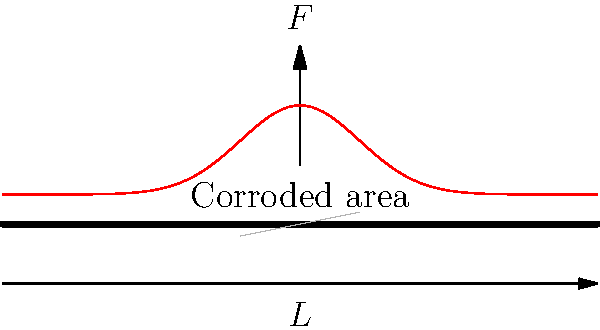Consider a corroded pipe section subjected to an axial load $F$ as shown in the figure. The pipe has length $L$ and the corroded area is located at the center. Using finite element analysis, the stress distribution along the pipe's length is plotted (red curve). What can be inferred about the stress concentration in the corroded area, and how might this affect the pipe's integrity over time? To analyze the stress distribution in the corroded pipe section:

1. Observe the stress distribution curve (red line):
   - The curve shows a peak at the center of the pipe where the corrosion is located.

2. Understand stress concentration:
   - Stress concentration occurs in areas where there are sudden changes in geometry or material properties.
   - The corroded area represents a reduction in pipe wall thickness, causing a stress concentration.

3. Analyze the peak stress:
   - The maximum stress occurs at the center of the corroded area.
   - This peak stress is significantly higher than the stress in the uncorroded sections.

4. Consider Saint-Venant's principle:
   - The stress concentration effect diminishes as we move away from the corroded area.

5. Evaluate the impact on pipe integrity:
   - The higher stress in the corroded area increases the risk of failure.
   - Over time, this stress concentration can lead to:
     a) Further corrosion acceleration
     b) Crack initiation and propagation
     c) Potential pipe rupture under continued loading

6. Long-term effects:
   - Cyclic loading may cause fatigue failure, starting at the high-stress region.
   - The corroded area may continue to deteriorate, further increasing the stress concentration.

7. Finite Element Analysis (FEA) implications:
   - FEA allows for accurate prediction of stress distribution in complex geometries.
   - It helps identify critical areas prone to failure, guiding maintenance and replacement decisions.
Answer: Stress concentration in the corroded area significantly increases local stress, potentially leading to accelerated deterioration and failure of the pipe over time. 